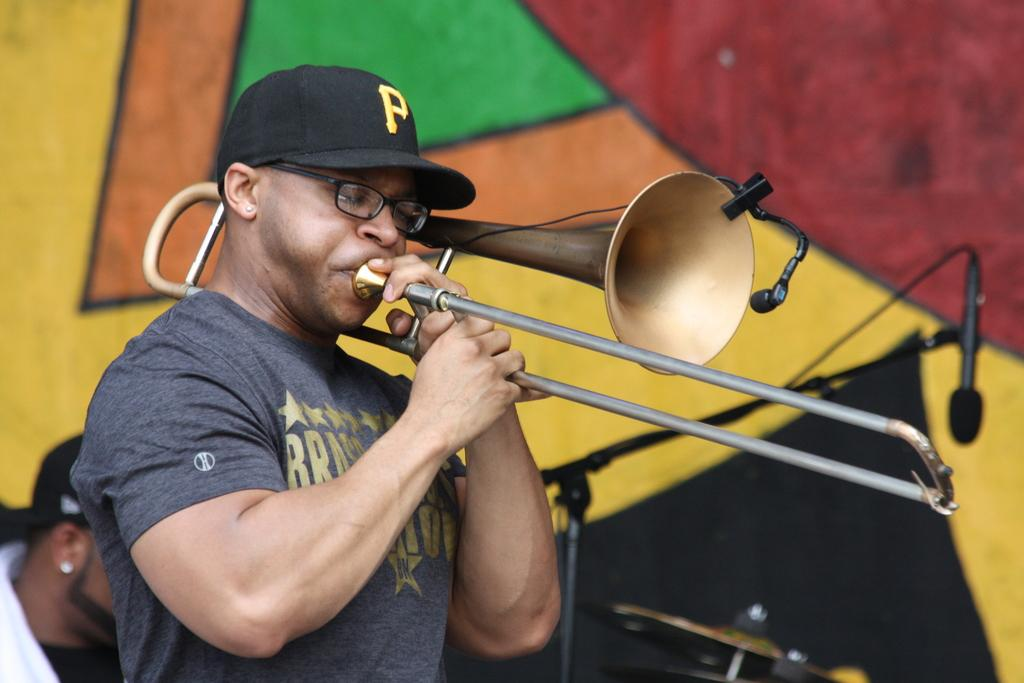What is the man in the image doing? The man is playing a musical instrument. What object is present that might be used for amplifying sound? There is a microphone in the image. Can you describe the other person in the image? There is another person in the image, but their actions or role are not specified. How does the man tie a knot with the musical instrument in the image? There is no knot or tying activity involving the musical instrument in the image. 